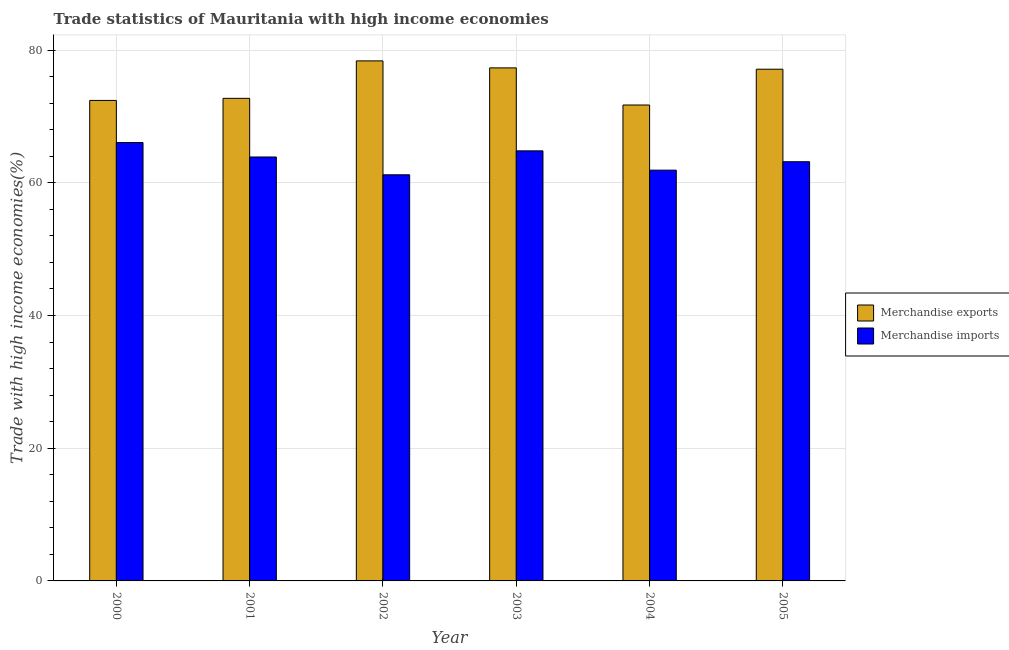How many bars are there on the 2nd tick from the right?
Your answer should be very brief. 2. What is the label of the 2nd group of bars from the left?
Your response must be concise. 2001. In how many cases, is the number of bars for a given year not equal to the number of legend labels?
Provide a succinct answer. 0. What is the merchandise exports in 2005?
Keep it short and to the point. 77.11. Across all years, what is the maximum merchandise exports?
Your answer should be very brief. 78.37. Across all years, what is the minimum merchandise exports?
Ensure brevity in your answer.  71.72. In which year was the merchandise imports maximum?
Offer a very short reply. 2000. In which year was the merchandise imports minimum?
Provide a short and direct response. 2002. What is the total merchandise imports in the graph?
Offer a very short reply. 381.03. What is the difference between the merchandise exports in 2000 and that in 2001?
Offer a terse response. -0.31. What is the difference between the merchandise exports in 2004 and the merchandise imports in 2002?
Provide a short and direct response. -6.65. What is the average merchandise exports per year?
Your response must be concise. 74.94. In the year 2005, what is the difference between the merchandise exports and merchandise imports?
Offer a very short reply. 0. What is the ratio of the merchandise exports in 2003 to that in 2004?
Your answer should be compact. 1.08. Is the merchandise exports in 2000 less than that in 2004?
Offer a very short reply. No. What is the difference between the highest and the second highest merchandise exports?
Your answer should be very brief. 1.06. What is the difference between the highest and the lowest merchandise exports?
Offer a terse response. 6.65. Are all the bars in the graph horizontal?
Your answer should be very brief. No. What is the difference between two consecutive major ticks on the Y-axis?
Give a very brief answer. 20. Are the values on the major ticks of Y-axis written in scientific E-notation?
Keep it short and to the point. No. Where does the legend appear in the graph?
Ensure brevity in your answer.  Center right. How many legend labels are there?
Offer a very short reply. 2. What is the title of the graph?
Provide a succinct answer. Trade statistics of Mauritania with high income economies. Does "Methane" appear as one of the legend labels in the graph?
Your answer should be compact. No. What is the label or title of the X-axis?
Your answer should be compact. Year. What is the label or title of the Y-axis?
Provide a short and direct response. Trade with high income economies(%). What is the Trade with high income economies(%) in Merchandise exports in 2000?
Make the answer very short. 72.41. What is the Trade with high income economies(%) in Merchandise imports in 2000?
Your answer should be very brief. 66.06. What is the Trade with high income economies(%) in Merchandise exports in 2001?
Give a very brief answer. 72.72. What is the Trade with high income economies(%) of Merchandise imports in 2001?
Your answer should be very brief. 63.89. What is the Trade with high income economies(%) of Merchandise exports in 2002?
Keep it short and to the point. 78.37. What is the Trade with high income economies(%) of Merchandise imports in 2002?
Make the answer very short. 61.2. What is the Trade with high income economies(%) in Merchandise exports in 2003?
Keep it short and to the point. 77.31. What is the Trade with high income economies(%) of Merchandise imports in 2003?
Your response must be concise. 64.81. What is the Trade with high income economies(%) in Merchandise exports in 2004?
Keep it short and to the point. 71.72. What is the Trade with high income economies(%) of Merchandise imports in 2004?
Your answer should be compact. 61.9. What is the Trade with high income economies(%) in Merchandise exports in 2005?
Your response must be concise. 77.11. What is the Trade with high income economies(%) in Merchandise imports in 2005?
Ensure brevity in your answer.  63.17. Across all years, what is the maximum Trade with high income economies(%) of Merchandise exports?
Provide a succinct answer. 78.37. Across all years, what is the maximum Trade with high income economies(%) in Merchandise imports?
Provide a succinct answer. 66.06. Across all years, what is the minimum Trade with high income economies(%) of Merchandise exports?
Offer a very short reply. 71.72. Across all years, what is the minimum Trade with high income economies(%) of Merchandise imports?
Ensure brevity in your answer.  61.2. What is the total Trade with high income economies(%) of Merchandise exports in the graph?
Make the answer very short. 449.64. What is the total Trade with high income economies(%) in Merchandise imports in the graph?
Provide a succinct answer. 381.03. What is the difference between the Trade with high income economies(%) in Merchandise exports in 2000 and that in 2001?
Your answer should be compact. -0.31. What is the difference between the Trade with high income economies(%) of Merchandise imports in 2000 and that in 2001?
Your answer should be compact. 2.18. What is the difference between the Trade with high income economies(%) in Merchandise exports in 2000 and that in 2002?
Keep it short and to the point. -5.96. What is the difference between the Trade with high income economies(%) of Merchandise imports in 2000 and that in 2002?
Offer a terse response. 4.86. What is the difference between the Trade with high income economies(%) in Merchandise exports in 2000 and that in 2003?
Provide a short and direct response. -4.9. What is the difference between the Trade with high income economies(%) of Merchandise imports in 2000 and that in 2003?
Your answer should be very brief. 1.25. What is the difference between the Trade with high income economies(%) of Merchandise exports in 2000 and that in 2004?
Your response must be concise. 0.69. What is the difference between the Trade with high income economies(%) of Merchandise imports in 2000 and that in 2004?
Ensure brevity in your answer.  4.16. What is the difference between the Trade with high income economies(%) of Merchandise exports in 2000 and that in 2005?
Ensure brevity in your answer.  -4.7. What is the difference between the Trade with high income economies(%) in Merchandise imports in 2000 and that in 2005?
Provide a short and direct response. 2.89. What is the difference between the Trade with high income economies(%) of Merchandise exports in 2001 and that in 2002?
Give a very brief answer. -5.65. What is the difference between the Trade with high income economies(%) of Merchandise imports in 2001 and that in 2002?
Your response must be concise. 2.68. What is the difference between the Trade with high income economies(%) of Merchandise exports in 2001 and that in 2003?
Your answer should be very brief. -4.59. What is the difference between the Trade with high income economies(%) of Merchandise imports in 2001 and that in 2003?
Provide a short and direct response. -0.92. What is the difference between the Trade with high income economies(%) of Merchandise exports in 2001 and that in 2004?
Your answer should be very brief. 1. What is the difference between the Trade with high income economies(%) of Merchandise imports in 2001 and that in 2004?
Offer a terse response. 1.98. What is the difference between the Trade with high income economies(%) of Merchandise exports in 2001 and that in 2005?
Make the answer very short. -4.39. What is the difference between the Trade with high income economies(%) of Merchandise imports in 2001 and that in 2005?
Make the answer very short. 0.72. What is the difference between the Trade with high income economies(%) in Merchandise exports in 2002 and that in 2003?
Provide a succinct answer. 1.06. What is the difference between the Trade with high income economies(%) of Merchandise imports in 2002 and that in 2003?
Keep it short and to the point. -3.61. What is the difference between the Trade with high income economies(%) in Merchandise exports in 2002 and that in 2004?
Offer a terse response. 6.65. What is the difference between the Trade with high income economies(%) in Merchandise imports in 2002 and that in 2004?
Make the answer very short. -0.7. What is the difference between the Trade with high income economies(%) in Merchandise exports in 2002 and that in 2005?
Provide a short and direct response. 1.26. What is the difference between the Trade with high income economies(%) of Merchandise imports in 2002 and that in 2005?
Ensure brevity in your answer.  -1.97. What is the difference between the Trade with high income economies(%) of Merchandise exports in 2003 and that in 2004?
Keep it short and to the point. 5.59. What is the difference between the Trade with high income economies(%) in Merchandise imports in 2003 and that in 2004?
Ensure brevity in your answer.  2.91. What is the difference between the Trade with high income economies(%) of Merchandise exports in 2003 and that in 2005?
Your answer should be very brief. 0.2. What is the difference between the Trade with high income economies(%) in Merchandise imports in 2003 and that in 2005?
Ensure brevity in your answer.  1.64. What is the difference between the Trade with high income economies(%) of Merchandise exports in 2004 and that in 2005?
Give a very brief answer. -5.39. What is the difference between the Trade with high income economies(%) of Merchandise imports in 2004 and that in 2005?
Offer a very short reply. -1.27. What is the difference between the Trade with high income economies(%) of Merchandise exports in 2000 and the Trade with high income economies(%) of Merchandise imports in 2001?
Make the answer very short. 8.52. What is the difference between the Trade with high income economies(%) of Merchandise exports in 2000 and the Trade with high income economies(%) of Merchandise imports in 2002?
Ensure brevity in your answer.  11.21. What is the difference between the Trade with high income economies(%) of Merchandise exports in 2000 and the Trade with high income economies(%) of Merchandise imports in 2003?
Keep it short and to the point. 7.6. What is the difference between the Trade with high income economies(%) of Merchandise exports in 2000 and the Trade with high income economies(%) of Merchandise imports in 2004?
Offer a terse response. 10.51. What is the difference between the Trade with high income economies(%) of Merchandise exports in 2000 and the Trade with high income economies(%) of Merchandise imports in 2005?
Provide a short and direct response. 9.24. What is the difference between the Trade with high income economies(%) of Merchandise exports in 2001 and the Trade with high income economies(%) of Merchandise imports in 2002?
Offer a very short reply. 11.52. What is the difference between the Trade with high income economies(%) in Merchandise exports in 2001 and the Trade with high income economies(%) in Merchandise imports in 2003?
Give a very brief answer. 7.91. What is the difference between the Trade with high income economies(%) of Merchandise exports in 2001 and the Trade with high income economies(%) of Merchandise imports in 2004?
Offer a terse response. 10.82. What is the difference between the Trade with high income economies(%) of Merchandise exports in 2001 and the Trade with high income economies(%) of Merchandise imports in 2005?
Your answer should be compact. 9.55. What is the difference between the Trade with high income economies(%) of Merchandise exports in 2002 and the Trade with high income economies(%) of Merchandise imports in 2003?
Your response must be concise. 13.56. What is the difference between the Trade with high income economies(%) in Merchandise exports in 2002 and the Trade with high income economies(%) in Merchandise imports in 2004?
Keep it short and to the point. 16.47. What is the difference between the Trade with high income economies(%) of Merchandise exports in 2002 and the Trade with high income economies(%) of Merchandise imports in 2005?
Give a very brief answer. 15.2. What is the difference between the Trade with high income economies(%) in Merchandise exports in 2003 and the Trade with high income economies(%) in Merchandise imports in 2004?
Your answer should be compact. 15.41. What is the difference between the Trade with high income economies(%) of Merchandise exports in 2003 and the Trade with high income economies(%) of Merchandise imports in 2005?
Your answer should be compact. 14.14. What is the difference between the Trade with high income economies(%) in Merchandise exports in 2004 and the Trade with high income economies(%) in Merchandise imports in 2005?
Keep it short and to the point. 8.55. What is the average Trade with high income economies(%) in Merchandise exports per year?
Ensure brevity in your answer.  74.94. What is the average Trade with high income economies(%) in Merchandise imports per year?
Make the answer very short. 63.51. In the year 2000, what is the difference between the Trade with high income economies(%) of Merchandise exports and Trade with high income economies(%) of Merchandise imports?
Give a very brief answer. 6.35. In the year 2001, what is the difference between the Trade with high income economies(%) in Merchandise exports and Trade with high income economies(%) in Merchandise imports?
Provide a short and direct response. 8.84. In the year 2002, what is the difference between the Trade with high income economies(%) in Merchandise exports and Trade with high income economies(%) in Merchandise imports?
Keep it short and to the point. 17.17. In the year 2003, what is the difference between the Trade with high income economies(%) in Merchandise exports and Trade with high income economies(%) in Merchandise imports?
Your answer should be compact. 12.5. In the year 2004, what is the difference between the Trade with high income economies(%) of Merchandise exports and Trade with high income economies(%) of Merchandise imports?
Give a very brief answer. 9.82. In the year 2005, what is the difference between the Trade with high income economies(%) in Merchandise exports and Trade with high income economies(%) in Merchandise imports?
Your answer should be compact. 13.94. What is the ratio of the Trade with high income economies(%) of Merchandise exports in 2000 to that in 2001?
Offer a very short reply. 1. What is the ratio of the Trade with high income economies(%) of Merchandise imports in 2000 to that in 2001?
Provide a short and direct response. 1.03. What is the ratio of the Trade with high income economies(%) of Merchandise exports in 2000 to that in 2002?
Ensure brevity in your answer.  0.92. What is the ratio of the Trade with high income economies(%) in Merchandise imports in 2000 to that in 2002?
Give a very brief answer. 1.08. What is the ratio of the Trade with high income economies(%) of Merchandise exports in 2000 to that in 2003?
Provide a short and direct response. 0.94. What is the ratio of the Trade with high income economies(%) of Merchandise imports in 2000 to that in 2003?
Make the answer very short. 1.02. What is the ratio of the Trade with high income economies(%) of Merchandise exports in 2000 to that in 2004?
Your answer should be very brief. 1.01. What is the ratio of the Trade with high income economies(%) in Merchandise imports in 2000 to that in 2004?
Offer a terse response. 1.07. What is the ratio of the Trade with high income economies(%) in Merchandise exports in 2000 to that in 2005?
Ensure brevity in your answer.  0.94. What is the ratio of the Trade with high income economies(%) of Merchandise imports in 2000 to that in 2005?
Give a very brief answer. 1.05. What is the ratio of the Trade with high income economies(%) in Merchandise exports in 2001 to that in 2002?
Give a very brief answer. 0.93. What is the ratio of the Trade with high income economies(%) of Merchandise imports in 2001 to that in 2002?
Make the answer very short. 1.04. What is the ratio of the Trade with high income economies(%) of Merchandise exports in 2001 to that in 2003?
Your response must be concise. 0.94. What is the ratio of the Trade with high income economies(%) of Merchandise imports in 2001 to that in 2003?
Keep it short and to the point. 0.99. What is the ratio of the Trade with high income economies(%) in Merchandise exports in 2001 to that in 2004?
Make the answer very short. 1.01. What is the ratio of the Trade with high income economies(%) of Merchandise imports in 2001 to that in 2004?
Ensure brevity in your answer.  1.03. What is the ratio of the Trade with high income economies(%) of Merchandise exports in 2001 to that in 2005?
Offer a very short reply. 0.94. What is the ratio of the Trade with high income economies(%) in Merchandise imports in 2001 to that in 2005?
Provide a succinct answer. 1.01. What is the ratio of the Trade with high income economies(%) in Merchandise exports in 2002 to that in 2003?
Your response must be concise. 1.01. What is the ratio of the Trade with high income economies(%) of Merchandise imports in 2002 to that in 2003?
Provide a short and direct response. 0.94. What is the ratio of the Trade with high income economies(%) in Merchandise exports in 2002 to that in 2004?
Ensure brevity in your answer.  1.09. What is the ratio of the Trade with high income economies(%) in Merchandise imports in 2002 to that in 2004?
Provide a succinct answer. 0.99. What is the ratio of the Trade with high income economies(%) of Merchandise exports in 2002 to that in 2005?
Make the answer very short. 1.02. What is the ratio of the Trade with high income economies(%) in Merchandise imports in 2002 to that in 2005?
Offer a terse response. 0.97. What is the ratio of the Trade with high income economies(%) of Merchandise exports in 2003 to that in 2004?
Your answer should be compact. 1.08. What is the ratio of the Trade with high income economies(%) of Merchandise imports in 2003 to that in 2004?
Ensure brevity in your answer.  1.05. What is the ratio of the Trade with high income economies(%) of Merchandise imports in 2003 to that in 2005?
Provide a succinct answer. 1.03. What is the ratio of the Trade with high income economies(%) of Merchandise exports in 2004 to that in 2005?
Give a very brief answer. 0.93. What is the ratio of the Trade with high income economies(%) of Merchandise imports in 2004 to that in 2005?
Offer a terse response. 0.98. What is the difference between the highest and the second highest Trade with high income economies(%) of Merchandise exports?
Your answer should be very brief. 1.06. What is the difference between the highest and the second highest Trade with high income economies(%) of Merchandise imports?
Offer a very short reply. 1.25. What is the difference between the highest and the lowest Trade with high income economies(%) in Merchandise exports?
Keep it short and to the point. 6.65. What is the difference between the highest and the lowest Trade with high income economies(%) of Merchandise imports?
Give a very brief answer. 4.86. 